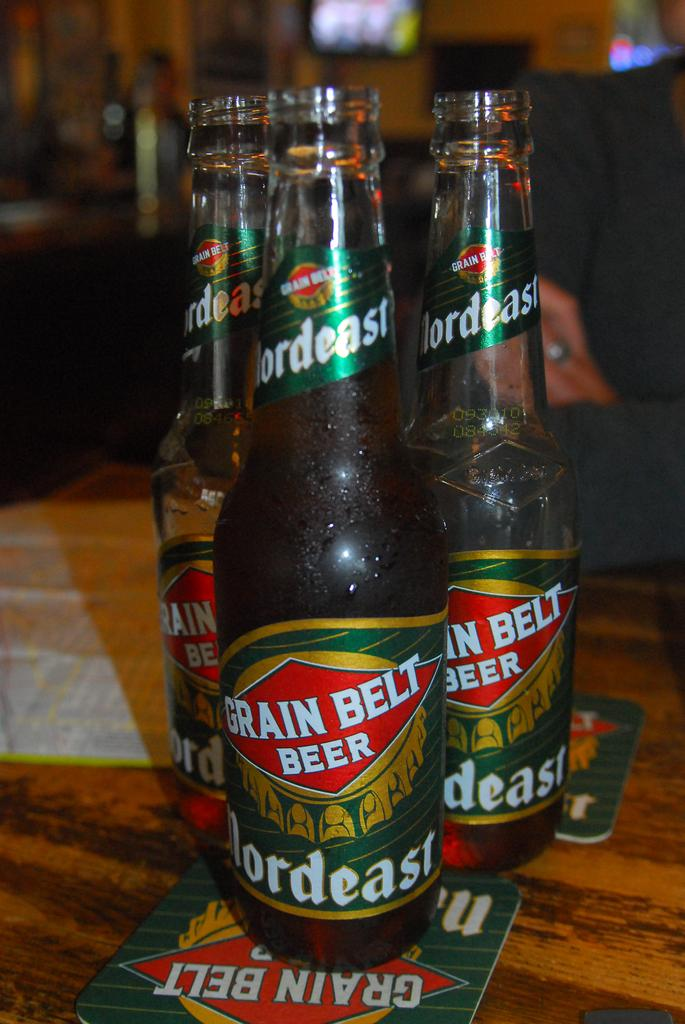<image>
Write a terse but informative summary of the picture. Three bottles of Grain Belt Beer on a table. 